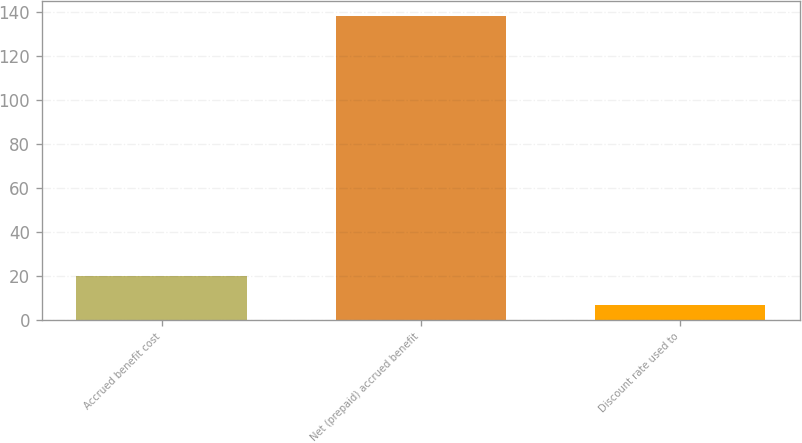Convert chart. <chart><loc_0><loc_0><loc_500><loc_500><bar_chart><fcel>Accrued benefit cost<fcel>Net (prepaid) accrued benefit<fcel>Discount rate used to<nl><fcel>19.88<fcel>138<fcel>6.75<nl></chart> 